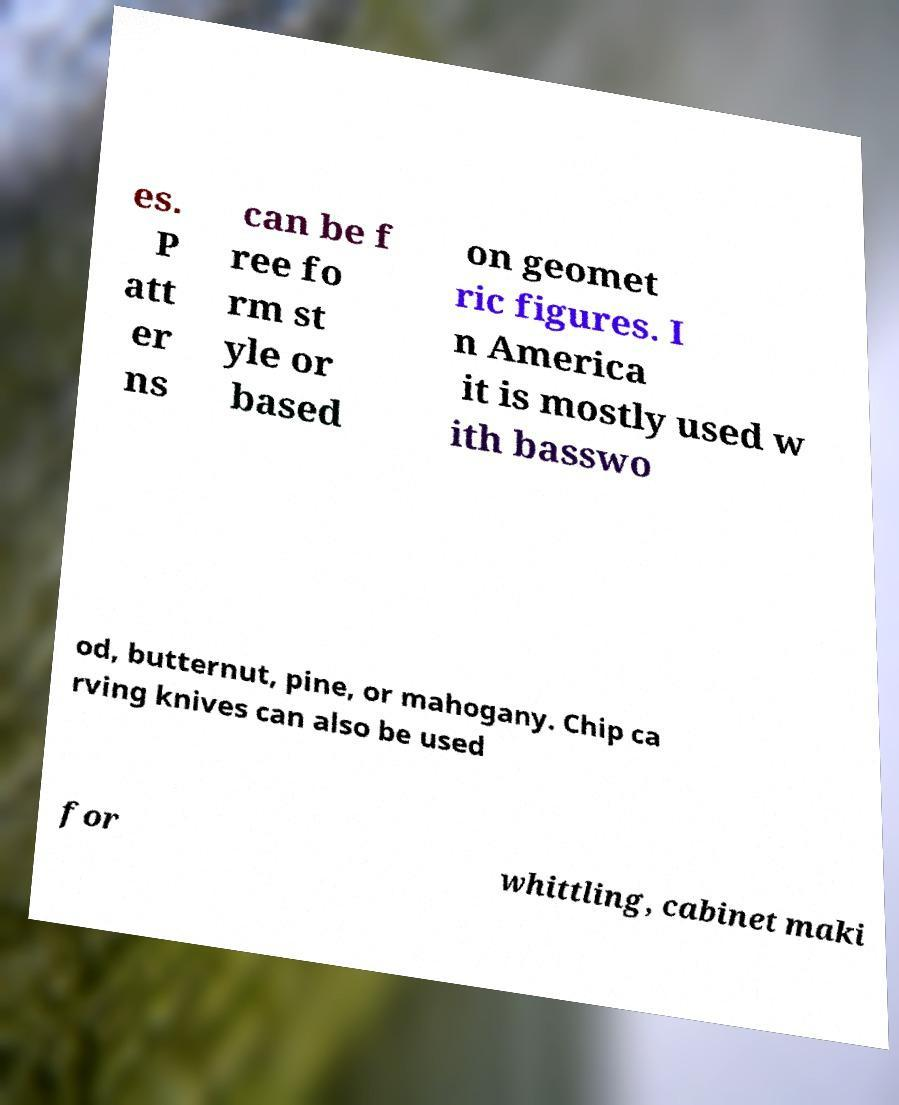Please read and relay the text visible in this image. What does it say? es. P att er ns can be f ree fo rm st yle or based on geomet ric figures. I n America it is mostly used w ith basswo od, butternut, pine, or mahogany. Chip ca rving knives can also be used for whittling, cabinet maki 